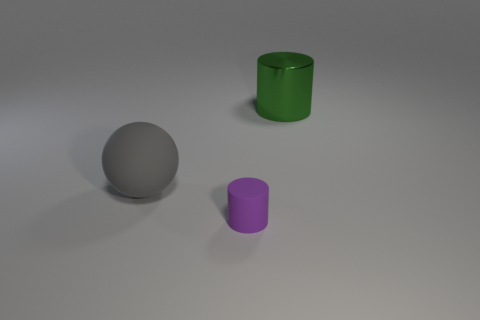Is the size of the gray matte thing the same as the green shiny thing? Although it's difficult to determine the exact scale without a reference object or measurements, the gray matte sphere and the green shiny cylinder appear to be of different sizes. The sphere seems slightly smaller in diameter compared to the height and diameter of the cylinder. 